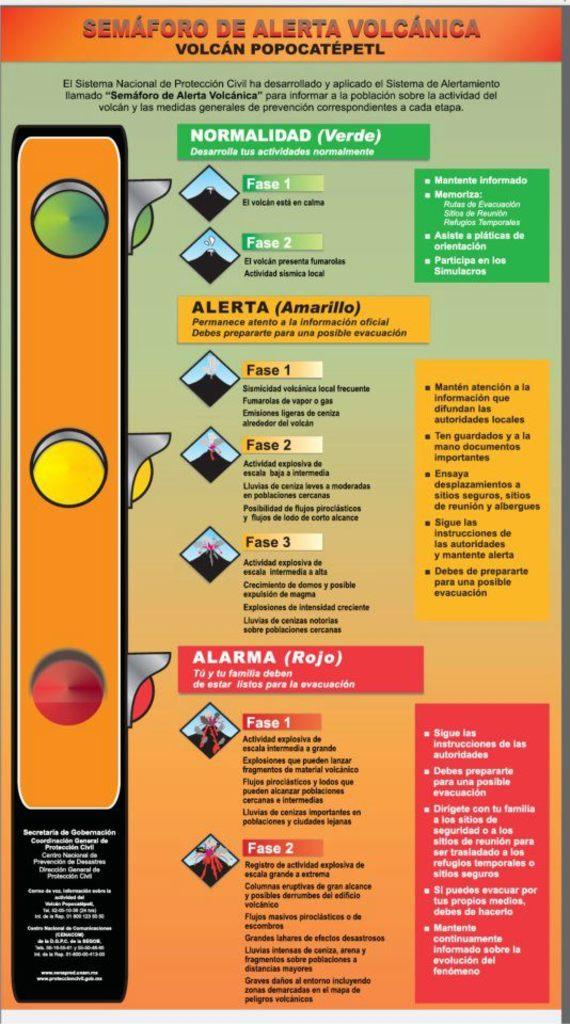<image>
Summarize the visual content of the image. A sign in Spanish details the different levels of a Volcano Alert. 